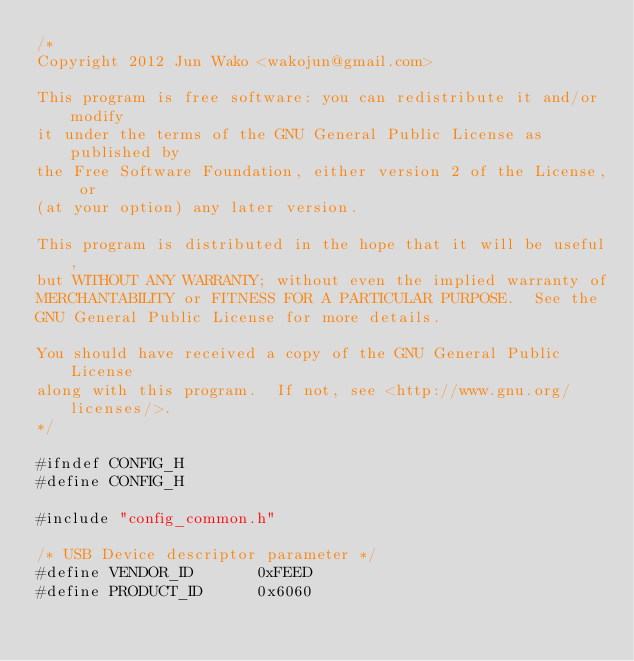<code> <loc_0><loc_0><loc_500><loc_500><_C_>/*
Copyright 2012 Jun Wako <wakojun@gmail.com>

This program is free software: you can redistribute it and/or modify
it under the terms of the GNU General Public License as published by
the Free Software Foundation, either version 2 of the License, or
(at your option) any later version.

This program is distributed in the hope that it will be useful,
but WITHOUT ANY WARRANTY; without even the implied warranty of
MERCHANTABILITY or FITNESS FOR A PARTICULAR PURPOSE.  See the
GNU General Public License for more details.

You should have received a copy of the GNU General Public License
along with this program.  If not, see <http://www.gnu.org/licenses/>.
*/

#ifndef CONFIG_H
#define CONFIG_H

#include "config_common.h"

/* USB Device descriptor parameter */
#define VENDOR_ID       0xFEED
#define PRODUCT_ID      0x6060</code> 